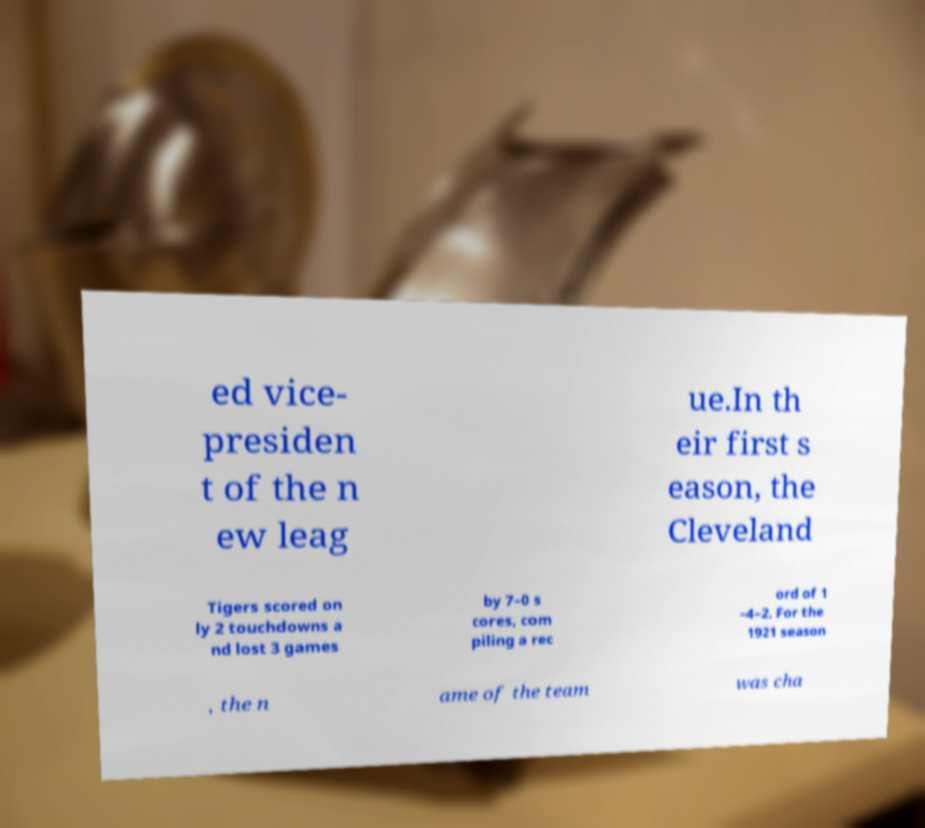There's text embedded in this image that I need extracted. Can you transcribe it verbatim? ed vice- presiden t of the n ew leag ue.In th eir first s eason, the Cleveland Tigers scored on ly 2 touchdowns a nd lost 3 games by 7–0 s cores, com piling a rec ord of 1 –4–2. For the 1921 season , the n ame of the team was cha 